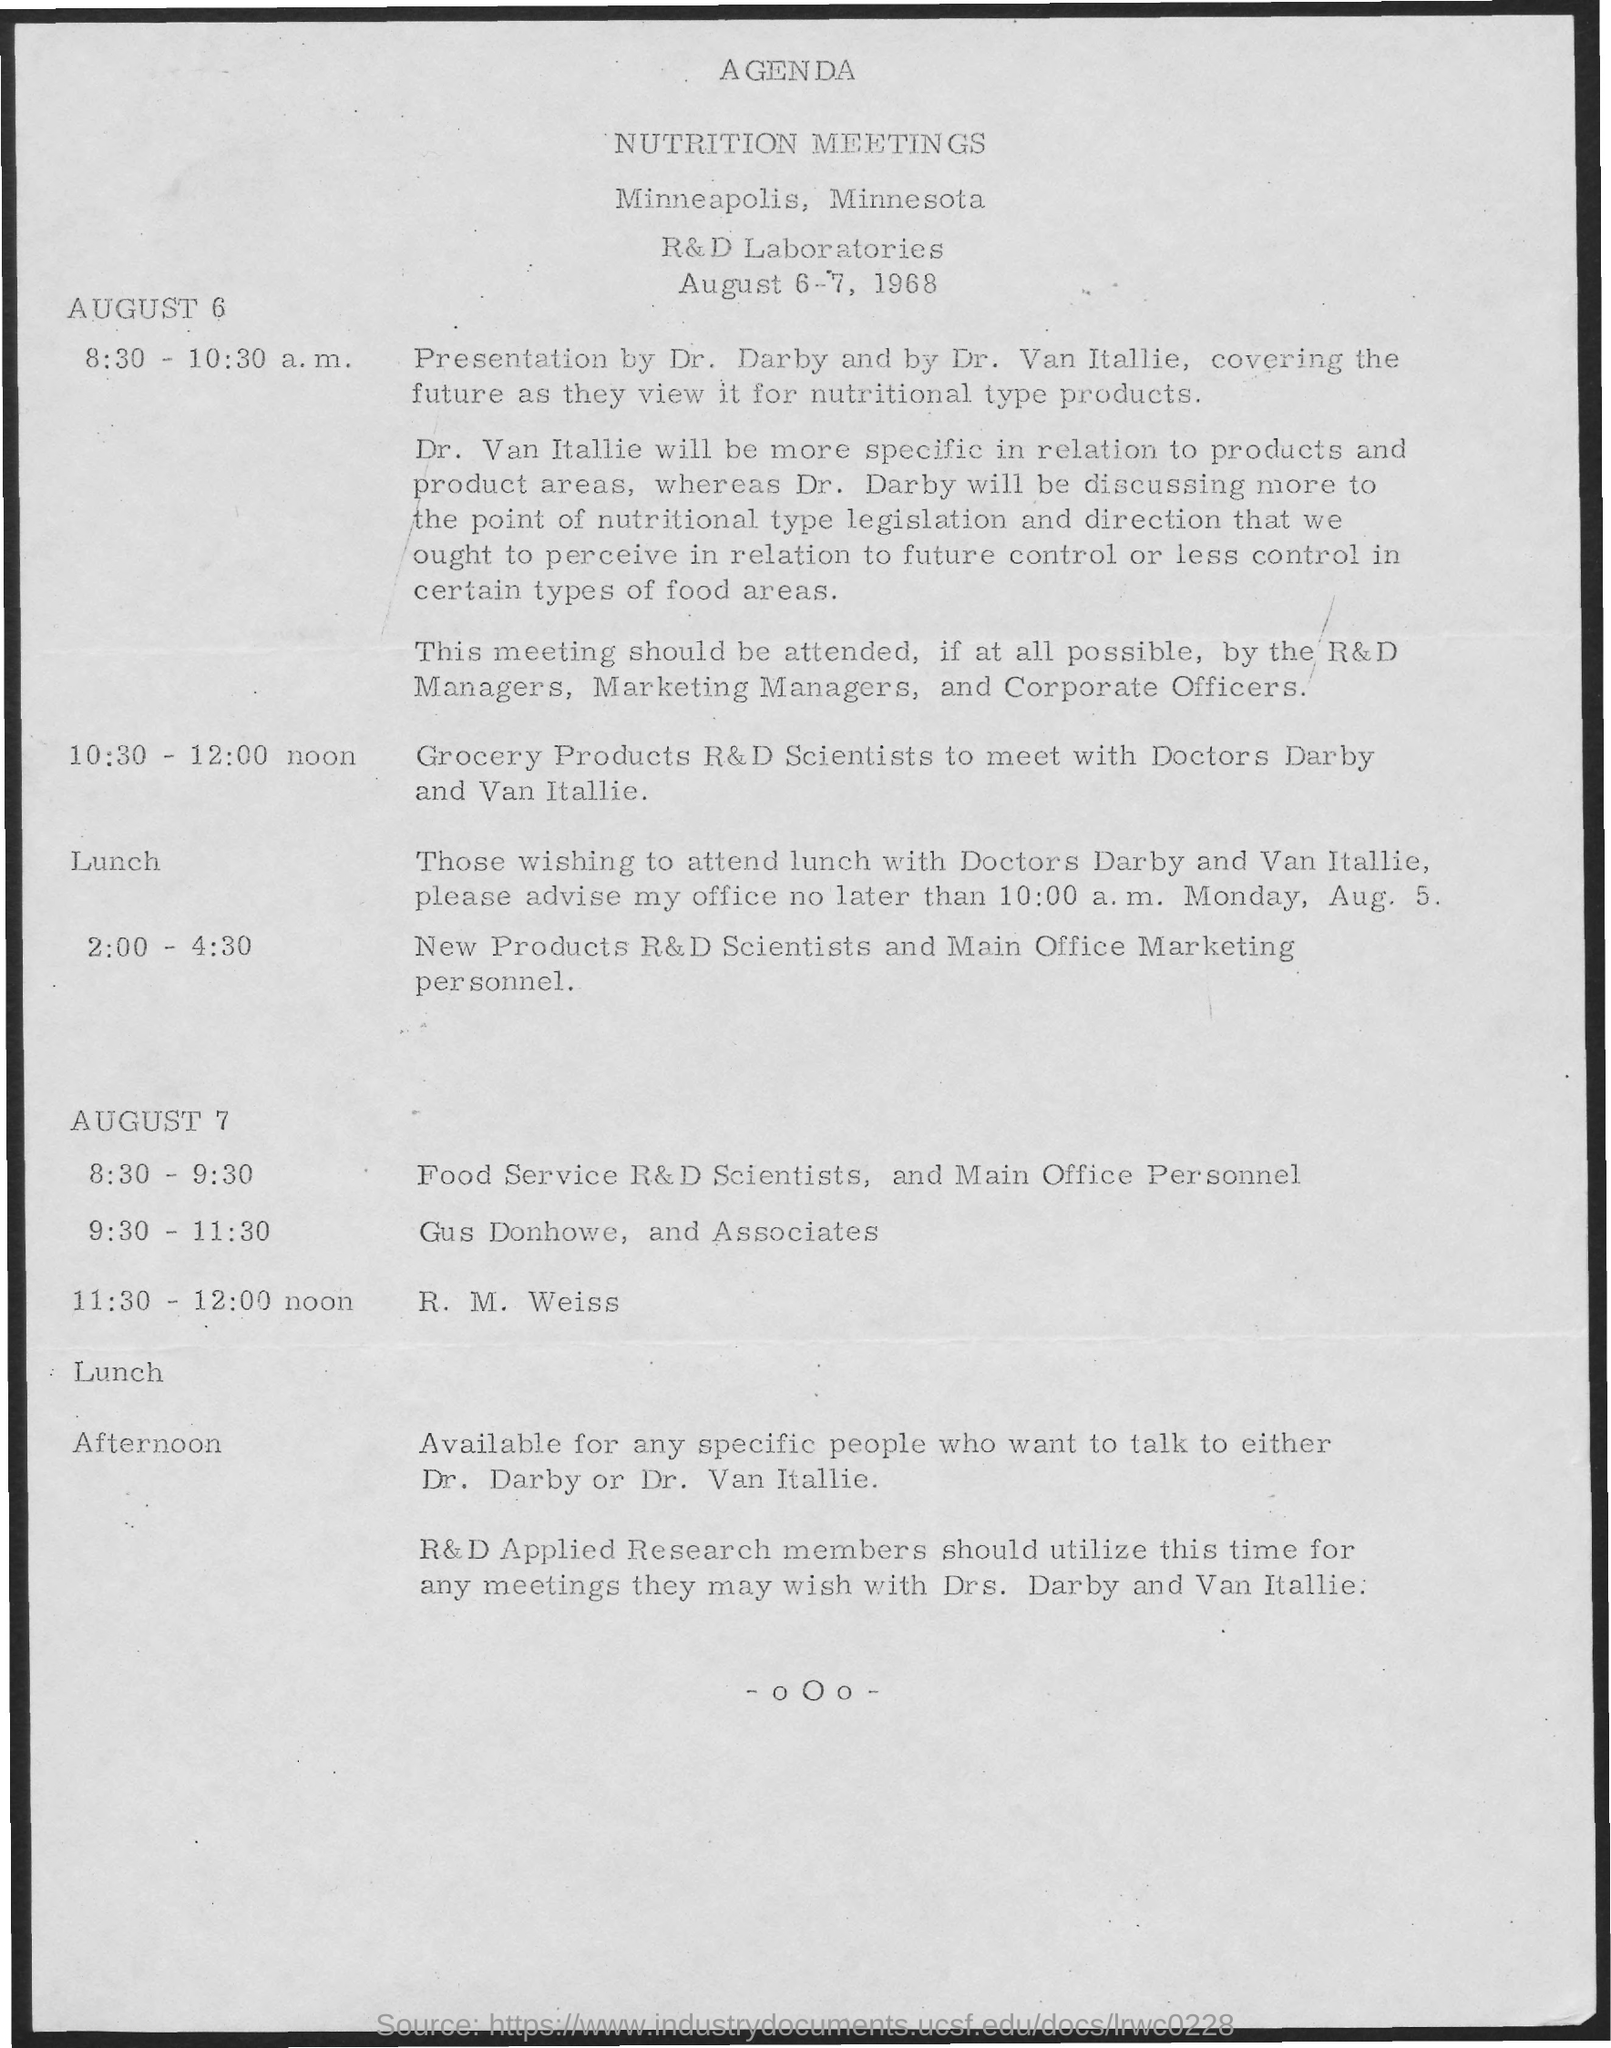Point out several critical features in this image. At 10:30 am to 12:00 noon, according to the agenda, the schedule includes a meeting between R&D scientists and two doctors, Grocery Products R&D. At 8:30-9:30, according to the given agenda, Food Service R&D Scientists, and Main office Personnel will be following the schedule. 